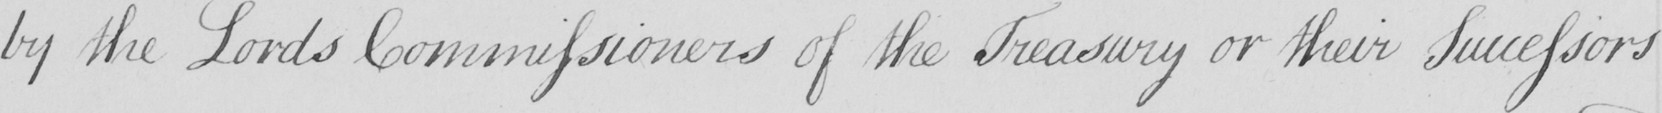What is written in this line of handwriting? by the Lords Commissioners of the Treasury or their Successors 